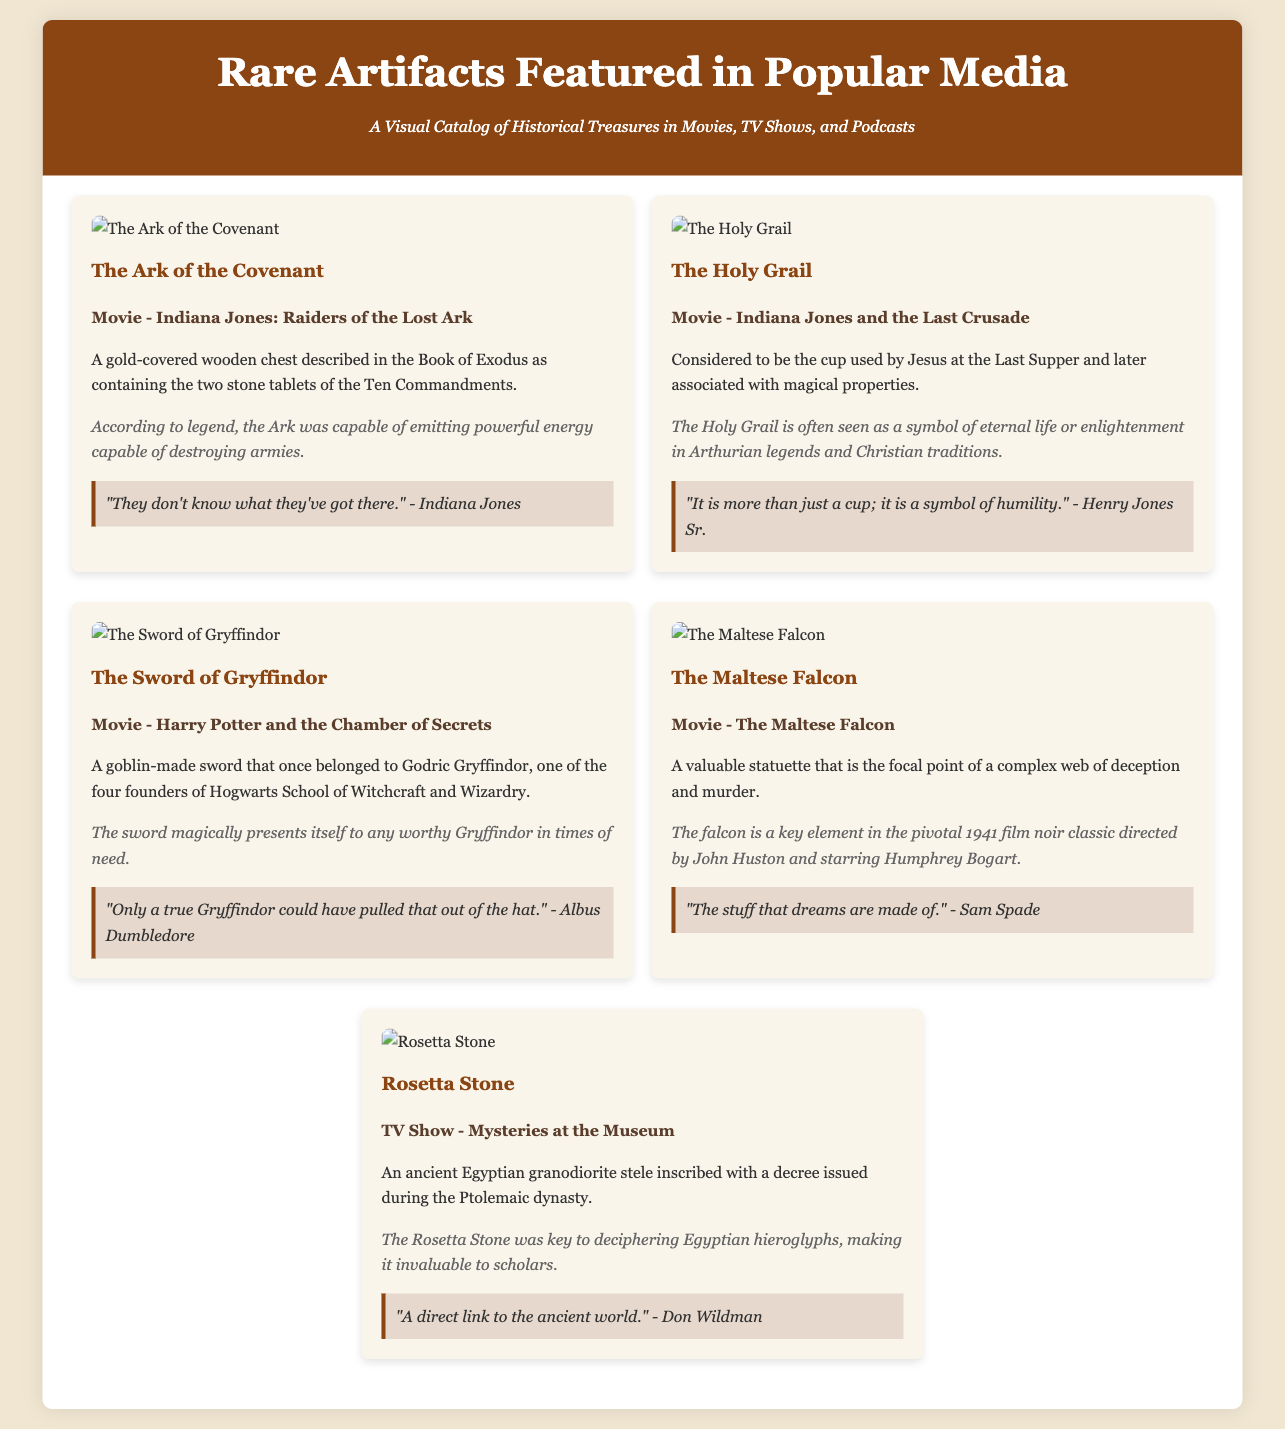what is the title of the infographic? The title of the infographic is prominently displayed at the top of the document.
Answer: Rare Artifacts Featured in Popular Media how many artifacts are featured in the document? The document lists the number of artifacts displayed in separate sections, where each artifact is contained within a clearly defined area.
Answer: 5 which artifact is associated with Indiana Jones? The document mentions multiple artifacts tied to the Indiana Jones franchise, providing descriptions and quotes referring to its representation in the media.
Answer: The Ark of the Covenant and The Holy Grail what is the media type for the Rosetta Stone? Each artifact includes information regarding its appearance in various forms of media, which can be categorized as movies, TV shows, or podcasts.
Answer: TV Show who said, "The stuff that dreams are made of"? The quotes attributed to characters or narrators are listed underneath each artifact and identify the speaker in relation to the artifact.
Answer: Sam Spade what does the Sword of Gryffindor symbolize? The description and trivia often extend beyond physical attributes to cover symbolism and significance, reflecting themes from the story.
Answer: Worthiness which artifact is described as a key to deciphering hieroglyphs? Each artifact includes a brief description that outlines its historical significance or role in history, which is also a point of trivia.
Answer: Rosetta Stone what year was The Maltese Falcon released? The document refers to significant details surrounding each artifact but does not explicitly mention release dates for the films.
Answer: 1941 